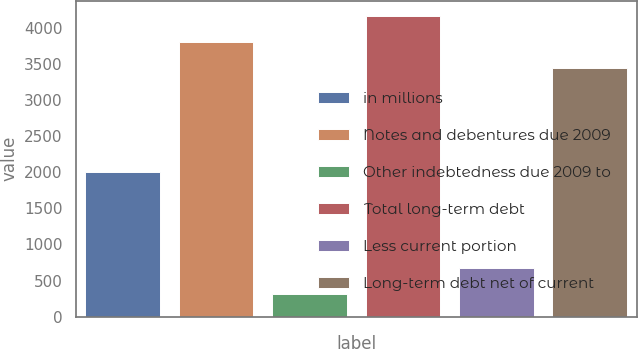Convert chart to OTSL. <chart><loc_0><loc_0><loc_500><loc_500><bar_chart><fcel>in millions<fcel>Notes and debentures due 2009<fcel>Other indebtedness due 2009 to<fcel>Total long-term debt<fcel>Less current portion<fcel>Long-term debt net of current<nl><fcel>2008<fcel>3803<fcel>320<fcel>4163<fcel>680<fcel>3443<nl></chart> 